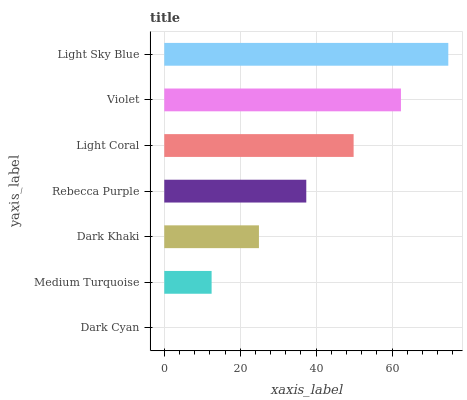Is Dark Cyan the minimum?
Answer yes or no. Yes. Is Light Sky Blue the maximum?
Answer yes or no. Yes. Is Medium Turquoise the minimum?
Answer yes or no. No. Is Medium Turquoise the maximum?
Answer yes or no. No. Is Medium Turquoise greater than Dark Cyan?
Answer yes or no. Yes. Is Dark Cyan less than Medium Turquoise?
Answer yes or no. Yes. Is Dark Cyan greater than Medium Turquoise?
Answer yes or no. No. Is Medium Turquoise less than Dark Cyan?
Answer yes or no. No. Is Rebecca Purple the high median?
Answer yes or no. Yes. Is Rebecca Purple the low median?
Answer yes or no. Yes. Is Light Sky Blue the high median?
Answer yes or no. No. Is Dark Khaki the low median?
Answer yes or no. No. 